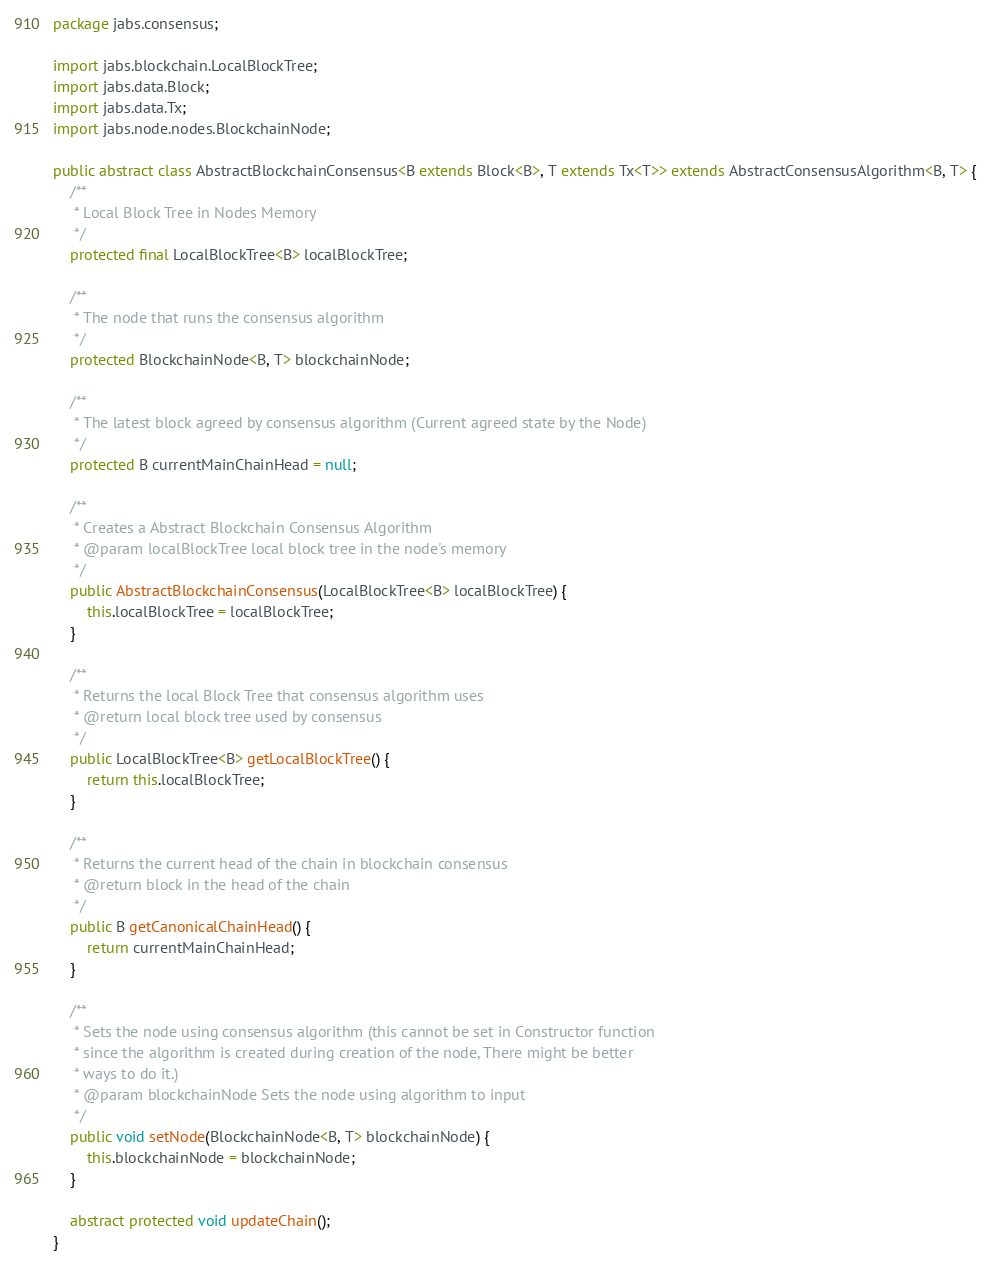<code> <loc_0><loc_0><loc_500><loc_500><_Java_>package jabs.consensus;

import jabs.blockchain.LocalBlockTree;
import jabs.data.Block;
import jabs.data.Tx;
import jabs.node.nodes.BlockchainNode;

public abstract class AbstractBlockchainConsensus<B extends Block<B>, T extends Tx<T>> extends AbstractConsensusAlgorithm<B, T> {
    /**
     * Local Block Tree in Nodes Memory
     */
    protected final LocalBlockTree<B> localBlockTree;

    /**
     * The node that runs the consensus algorithm
     */
    protected BlockchainNode<B, T> blockchainNode;

    /**
     * The latest block agreed by consensus algorithm (Current agreed state by the Node)
     */
    protected B currentMainChainHead = null;

    /**
     * Creates a Abstract Blockchain Consensus Algorithm
     * @param localBlockTree local block tree in the node's memory
     */
    public AbstractBlockchainConsensus(LocalBlockTree<B> localBlockTree) {
        this.localBlockTree = localBlockTree;
    }

    /**
     * Returns the local Block Tree that consensus algorithm uses
     * @return local block tree used by consensus
     */
    public LocalBlockTree<B> getLocalBlockTree() {
        return this.localBlockTree;
    }

    /**
     * Returns the current head of the chain in blockchain consensus
     * @return block in the head of the chain
     */
    public B getCanonicalChainHead() {
        return currentMainChainHead;
    }

    /**
     * Sets the node using consensus algorithm (this cannot be set in Constructor function
     * since the algorithm is created during creation of the node, There might be better
     * ways to do it.)
     * @param blockchainNode Sets the node using algorithm to input
     */
    public void setNode(BlockchainNode<B, T> blockchainNode) {
        this.blockchainNode = blockchainNode;
    }

    abstract protected void updateChain();
}
</code> 